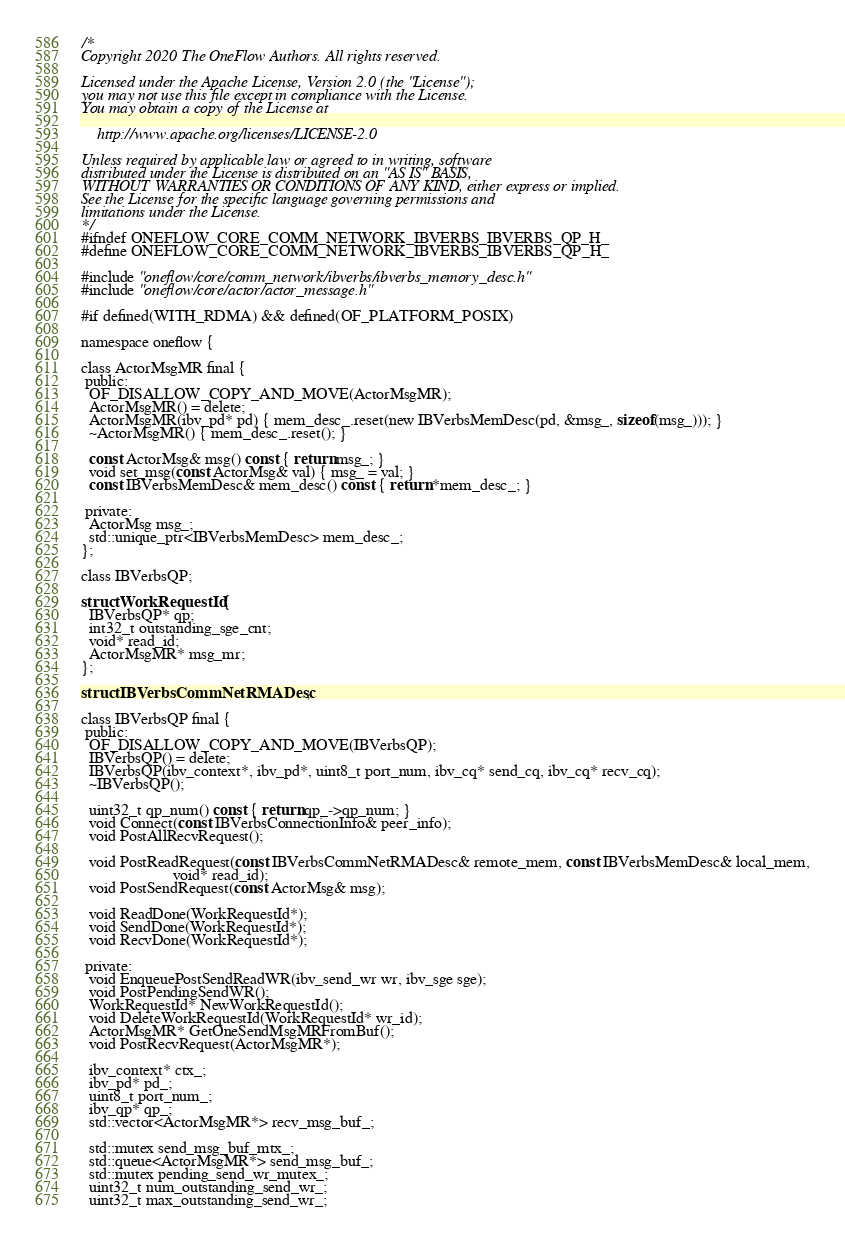Convert code to text. <code><loc_0><loc_0><loc_500><loc_500><_C_>/*
Copyright 2020 The OneFlow Authors. All rights reserved.

Licensed under the Apache License, Version 2.0 (the "License");
you may not use this file except in compliance with the License.
You may obtain a copy of the License at

    http://www.apache.org/licenses/LICENSE-2.0

Unless required by applicable law or agreed to in writing, software
distributed under the License is distributed on an "AS IS" BASIS,
WITHOUT WARRANTIES OR CONDITIONS OF ANY KIND, either express or implied.
See the License for the specific language governing permissions and
limitations under the License.
*/
#ifndef ONEFLOW_CORE_COMM_NETWORK_IBVERBS_IBVERBS_QP_H_
#define ONEFLOW_CORE_COMM_NETWORK_IBVERBS_IBVERBS_QP_H_

#include "oneflow/core/comm_network/ibverbs/ibverbs_memory_desc.h"
#include "oneflow/core/actor/actor_message.h"

#if defined(WITH_RDMA) && defined(OF_PLATFORM_POSIX)

namespace oneflow {

class ActorMsgMR final {
 public:
  OF_DISALLOW_COPY_AND_MOVE(ActorMsgMR);
  ActorMsgMR() = delete;
  ActorMsgMR(ibv_pd* pd) { mem_desc_.reset(new IBVerbsMemDesc(pd, &msg_, sizeof(msg_))); }
  ~ActorMsgMR() { mem_desc_.reset(); }

  const ActorMsg& msg() const { return msg_; }
  void set_msg(const ActorMsg& val) { msg_ = val; }
  const IBVerbsMemDesc& mem_desc() const { return *mem_desc_; }

 private:
  ActorMsg msg_;
  std::unique_ptr<IBVerbsMemDesc> mem_desc_;
};

class IBVerbsQP;

struct WorkRequestId {
  IBVerbsQP* qp;
  int32_t outstanding_sge_cnt;
  void* read_id;
  ActorMsgMR* msg_mr;
};

struct IBVerbsCommNetRMADesc;

class IBVerbsQP final {
 public:
  OF_DISALLOW_COPY_AND_MOVE(IBVerbsQP);
  IBVerbsQP() = delete;
  IBVerbsQP(ibv_context*, ibv_pd*, uint8_t port_num, ibv_cq* send_cq, ibv_cq* recv_cq);
  ~IBVerbsQP();

  uint32_t qp_num() const { return qp_->qp_num; }
  void Connect(const IBVerbsConnectionInfo& peer_info);
  void PostAllRecvRequest();

  void PostReadRequest(const IBVerbsCommNetRMADesc& remote_mem, const IBVerbsMemDesc& local_mem,
                       void* read_id);
  void PostSendRequest(const ActorMsg& msg);

  void ReadDone(WorkRequestId*);
  void SendDone(WorkRequestId*);
  void RecvDone(WorkRequestId*);

 private:
  void EnqueuePostSendReadWR(ibv_send_wr wr, ibv_sge sge);
  void PostPendingSendWR();
  WorkRequestId* NewWorkRequestId();
  void DeleteWorkRequestId(WorkRequestId* wr_id);
  ActorMsgMR* GetOneSendMsgMRFromBuf();
  void PostRecvRequest(ActorMsgMR*);

  ibv_context* ctx_;
  ibv_pd* pd_;
  uint8_t port_num_;
  ibv_qp* qp_;
  std::vector<ActorMsgMR*> recv_msg_buf_;

  std::mutex send_msg_buf_mtx_;
  std::queue<ActorMsgMR*> send_msg_buf_;
  std::mutex pending_send_wr_mutex_;
  uint32_t num_outstanding_send_wr_;
  uint32_t max_outstanding_send_wr_;</code> 